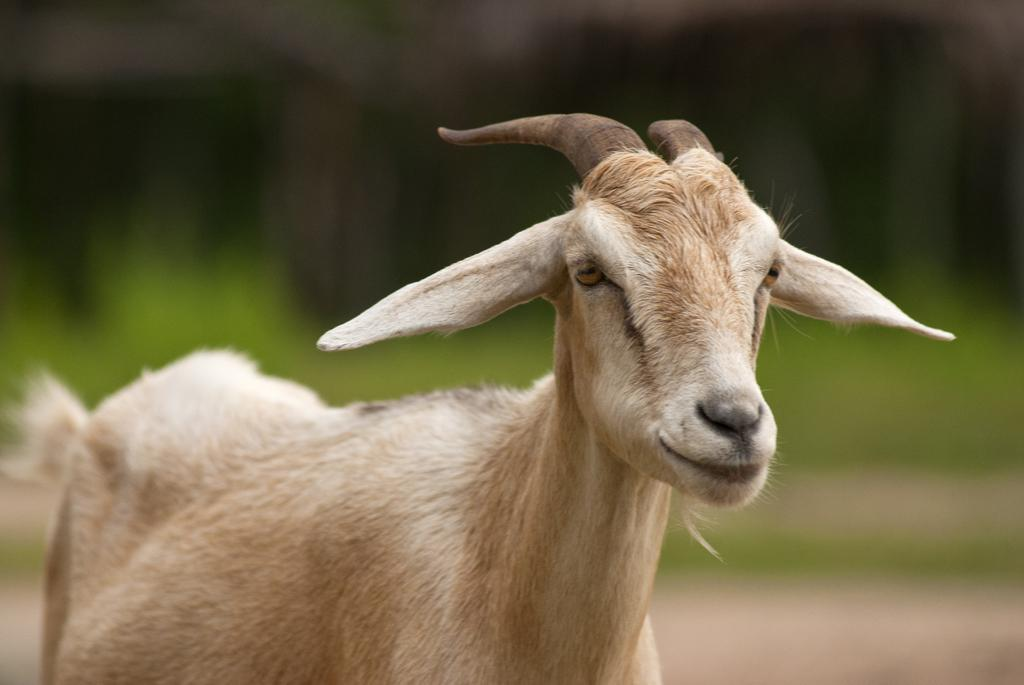What animal is the main subject of the image? There is a goat in the image. Can you describe the color of the goat? The goat is cream and white in color. Where is the goat positioned in the image? The goat is in the front of the image. What color is the background of the image? The background of the image is green. How would you describe the quality of the image in the background? The image is blurry in the background. What type of hat is the goat wearing in the image? The goat is not wearing a hat in the image; it is a goat and not a person. 